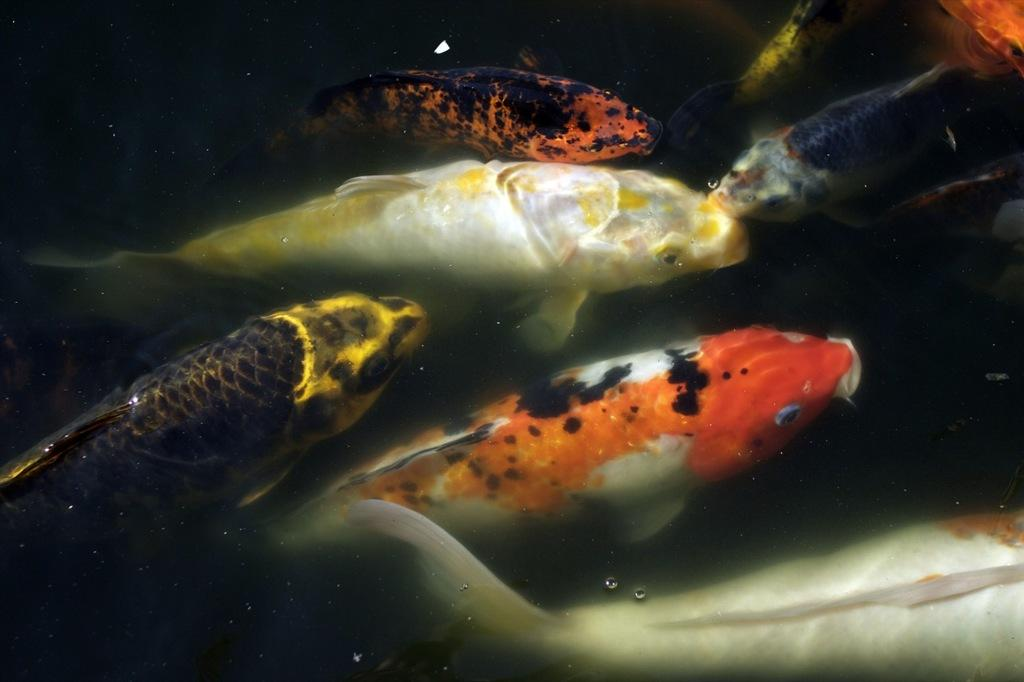What type of animals are in the image? There are fishes in the image. Where are the fishes located? The fishes are in water. Can you describe the appearance of the fishes? The fishes are of different colors. What type of stick can be seen in the image? There is no stick present in the image. What kind of society do the fishes belong to in the image? The image does not depict a society or social structure for the fishes. What type of beast is interacting with the fishes in the image? There is no beast present in the image; it only features fishes in water. 